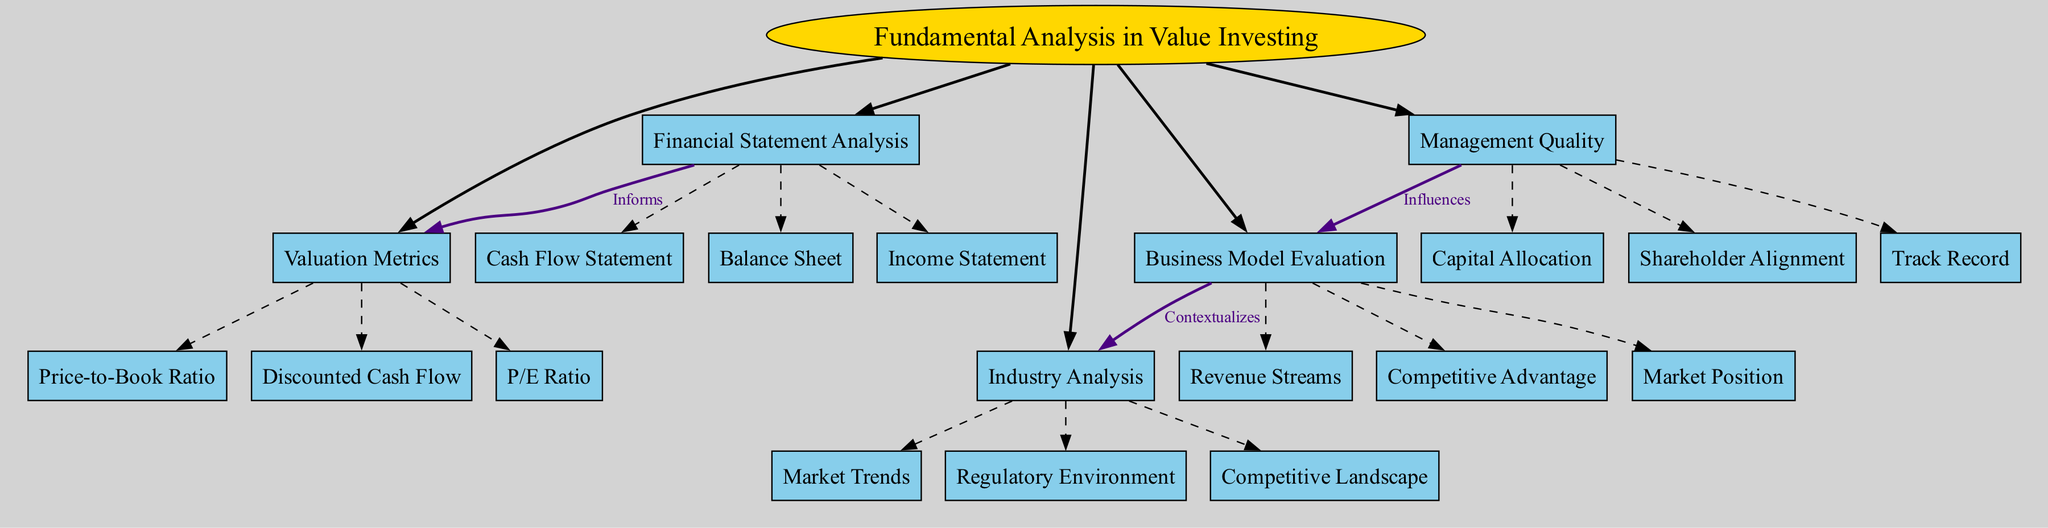What is the central concept of the diagram? The central concept is labeled "Fundamental Analysis in Value Investing" in the diagram, which is the main idea that encompasses all other components.
Answer: Fundamental Analysis in Value Investing How many main components are there? The diagram lists five main components branching from the central concept, which define key areas of focus in fundamental analysis.
Answer: 5 What sub-component falls under Financial Statement Analysis? The sub-components listed under Financial Statement Analysis include Balance Sheet, Income Statement, and Cash Flow Statement; any of these would correctly answer the question.
Answer: Balance Sheet (or Income Statement, or Cash Flow Statement) What relationship describes the connection between Financial Statement Analysis and Valuation Metrics? The connection is labeled "Informs" in the diagram, indicating that Financial Statement Analysis provides information that aids in determining Valuation Metrics.
Answer: Informs Which main component influences Business Model Evaluation? The diagram shows that Management Quality influences Business Model Evaluation, indicating that the quality of management impacts the assessment of a business model.
Answer: Management Quality What sub-component of Business Model Evaluation relates to market competition? The Competitive Advantage sub-component directly aligns with market competition, as it concerns the aspects of a business that enable it to outperform competitors.
Answer: Competitive Advantage How does Business Model Evaluation contextualize Industry Analysis? The diagram indicates that Business Model Evaluation provides a context for Industry Analysis, meaning an understanding of a business model helps to interpret industry factors.
Answer: Contextualizes Which valuation metric is used to assess earnings relative to the stock price? The P/E Ratio is a valuation metric that assesses a company's earnings in relation to its stock price, which is clearly shown in the Valuation Metrics section.
Answer: P/E Ratio What color represents the main components in the diagram? The main components are represented with a light blue color (#87CEEB) in the diagram, which distinguishes them from other elements.
Answer: Light blue 